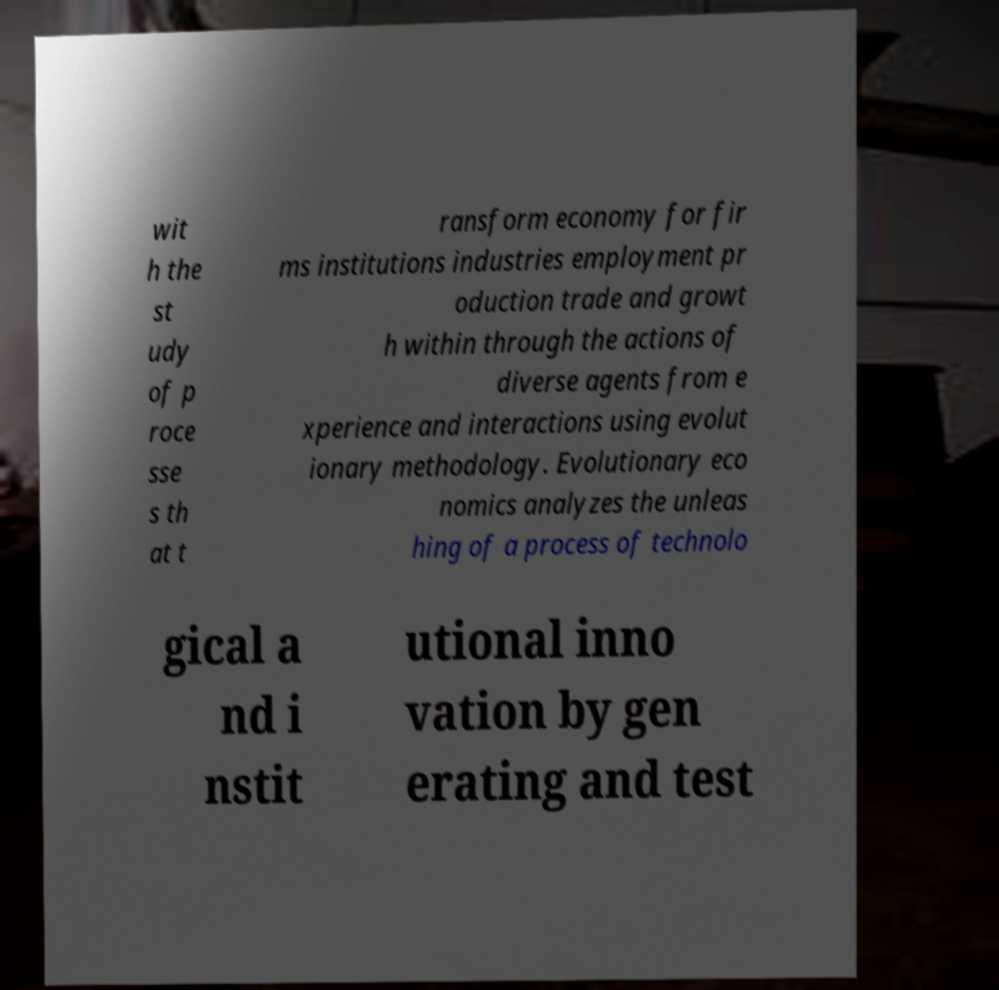Could you extract and type out the text from this image? wit h the st udy of p roce sse s th at t ransform economy for fir ms institutions industries employment pr oduction trade and growt h within through the actions of diverse agents from e xperience and interactions using evolut ionary methodology. Evolutionary eco nomics analyzes the unleas hing of a process of technolo gical a nd i nstit utional inno vation by gen erating and test 